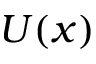<formula> <loc_0><loc_0><loc_500><loc_500>U ( x )</formula> 